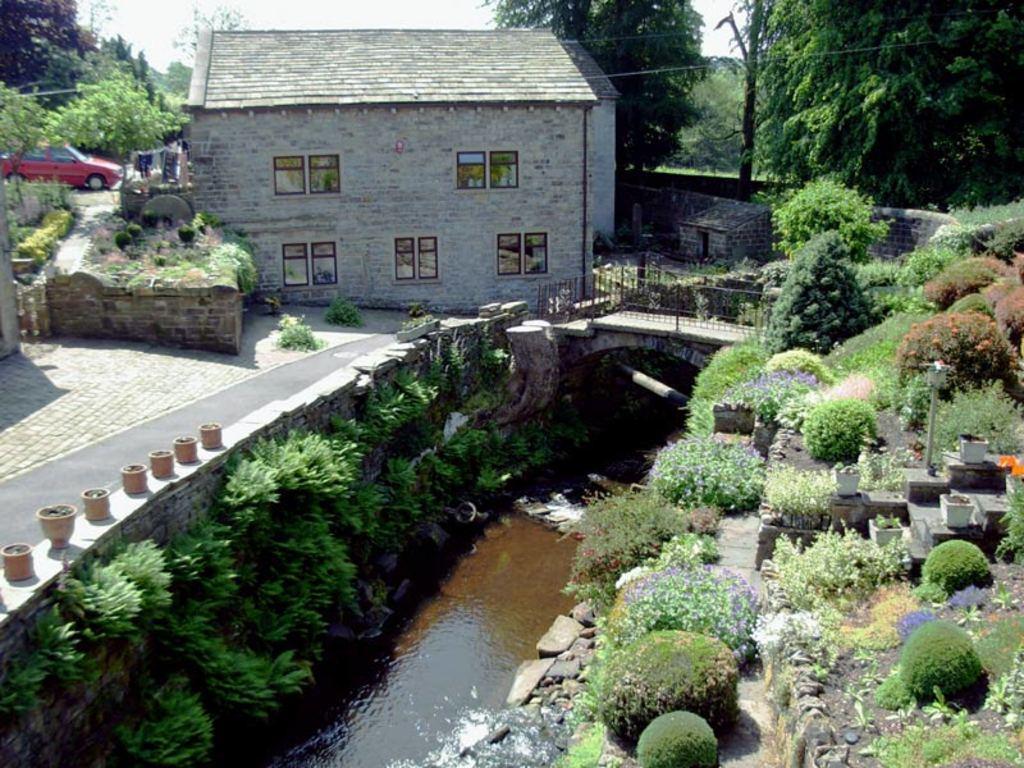Could you give a brief overview of what you see in this image? This image is taken outdoors. At the top of the image there is a sky. At the bottom of the image there is a pond with water. There are many plants on the ground and there are a few stones. In the background there are many trees and a few plants. A car is parked on the ground. In the middle of the image there is a house with walls, windows and a roof. There is a railing and there are a few spots on the wall. On the right side of the image there are many plants and there is a ground with grass on it. 